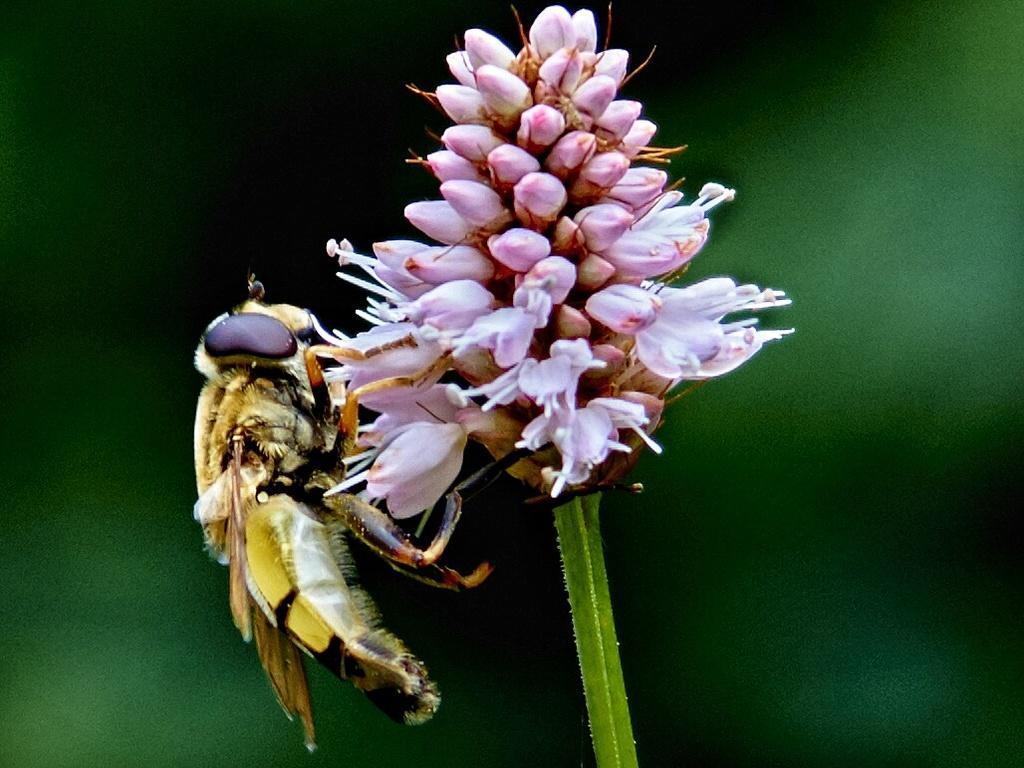Please provide a concise description of this image. There is an insect on the flowers. Here we can see flower buds and a stem. There is a blur background. 